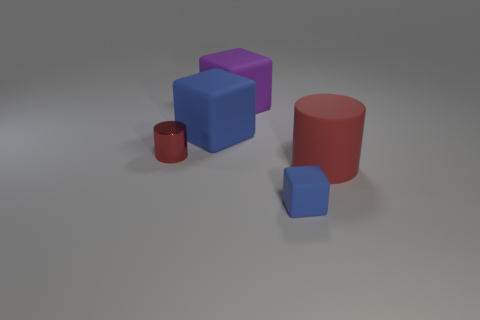How many blue blocks must be subtracted to get 1 blue blocks? 1 Add 3 purple blocks. How many objects exist? 8 Subtract all cyan cylinders. Subtract all blue balls. How many cylinders are left? 2 Subtract all cubes. How many objects are left? 2 Subtract 0 green cylinders. How many objects are left? 5 Subtract all large purple rubber things. Subtract all big blue things. How many objects are left? 3 Add 2 big blue matte things. How many big blue matte things are left? 3 Add 5 small purple shiny cubes. How many small purple shiny cubes exist? 5 